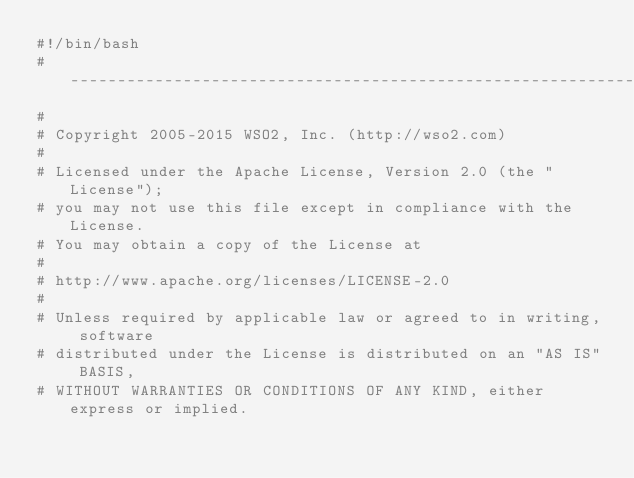<code> <loc_0><loc_0><loc_500><loc_500><_Bash_>#!/bin/bash
# ------------------------------------------------------------------------
#
# Copyright 2005-2015 WSO2, Inc. (http://wso2.com)
#
# Licensed under the Apache License, Version 2.0 (the "License");
# you may not use this file except in compliance with the License.
# You may obtain a copy of the License at
#
# http://www.apache.org/licenses/LICENSE-2.0
#
# Unless required by applicable law or agreed to in writing, software
# distributed under the License is distributed on an "AS IS" BASIS,
# WITHOUT WARRANTIES OR CONDITIONS OF ANY KIND, either express or implied.</code> 